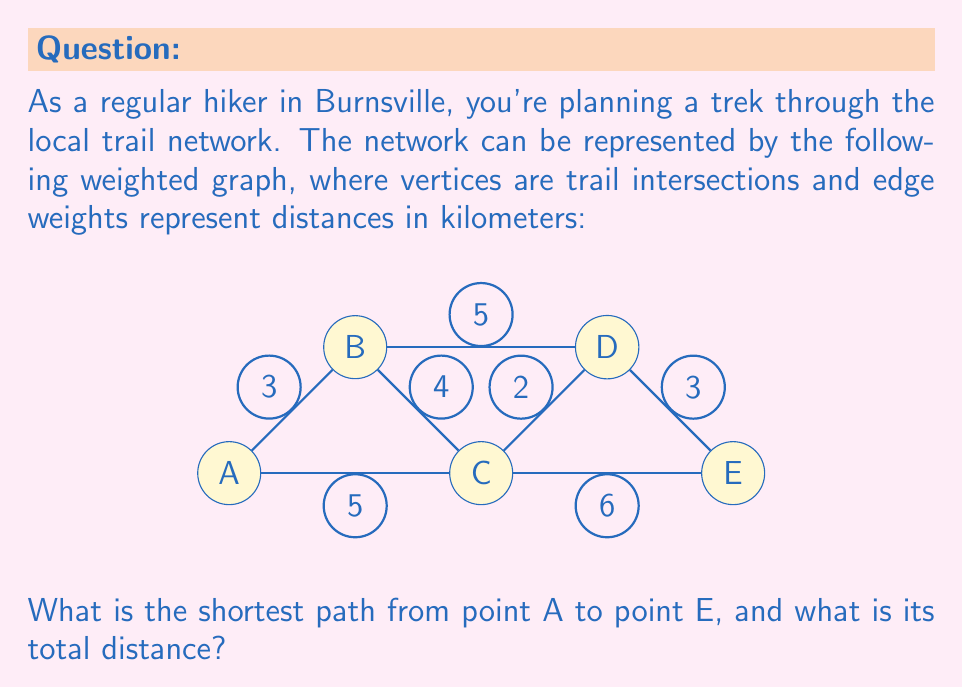What is the answer to this math problem? To solve this problem, we'll use Dijkstra's algorithm to find the shortest path from A to E. Let's go through the steps:

1) Initialize:
   - Distance to A: 0
   - Distance to all other vertices: ∞
   - Set of unvisited nodes: {A, B, C, D, E}

2) From A, we can reach:
   - B with distance 3
   - C with distance 5
   Update distances: A(0), B(3), C(5), D(∞), E(∞)
   Mark A as visited. Unvisited: {B, C, D, E}

3) Select B (smallest distance among unvisited):
   - Can reach C: 3 + 4 = 7 > current C(5), no update
   - Can reach D: 3 + 5 = 8
   Update distances: A(0), B(3), C(5), D(8), E(∞)
   Mark B as visited. Unvisited: {C, D, E}

4) Select C:
   - Can reach D: 5 + 2 = 7 < current D(8), update
   - Can reach E: 5 + 6 = 11
   Update distances: A(0), B(3), C(5), D(7), E(11)
   Mark C as visited. Unvisited: {D, E}

5) Select D:
   - Can reach E: 7 + 3 = 10 < current E(11), update
   Update distances: A(0), B(3), C(5), D(7), E(10)
   Mark D as visited. Unvisited: {E}

6) Select E (only remaining node):
   No more updates needed.

The shortest path is A → C → D → E with a total distance of 10 km.
Answer: A → C → D → E, 10 km 